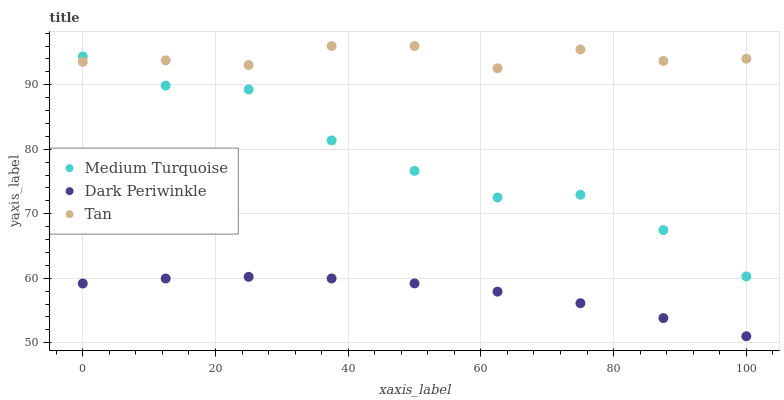Does Dark Periwinkle have the minimum area under the curve?
Answer yes or no. Yes. Does Tan have the maximum area under the curve?
Answer yes or no. Yes. Does Medium Turquoise have the minimum area under the curve?
Answer yes or no. No. Does Medium Turquoise have the maximum area under the curve?
Answer yes or no. No. Is Dark Periwinkle the smoothest?
Answer yes or no. Yes. Is Medium Turquoise the roughest?
Answer yes or no. Yes. Is Medium Turquoise the smoothest?
Answer yes or no. No. Is Dark Periwinkle the roughest?
Answer yes or no. No. Does Dark Periwinkle have the lowest value?
Answer yes or no. Yes. Does Medium Turquoise have the lowest value?
Answer yes or no. No. Does Tan have the highest value?
Answer yes or no. Yes. Does Medium Turquoise have the highest value?
Answer yes or no. No. Is Dark Periwinkle less than Medium Turquoise?
Answer yes or no. Yes. Is Medium Turquoise greater than Dark Periwinkle?
Answer yes or no. Yes. Does Tan intersect Medium Turquoise?
Answer yes or no. Yes. Is Tan less than Medium Turquoise?
Answer yes or no. No. Is Tan greater than Medium Turquoise?
Answer yes or no. No. Does Dark Periwinkle intersect Medium Turquoise?
Answer yes or no. No. 